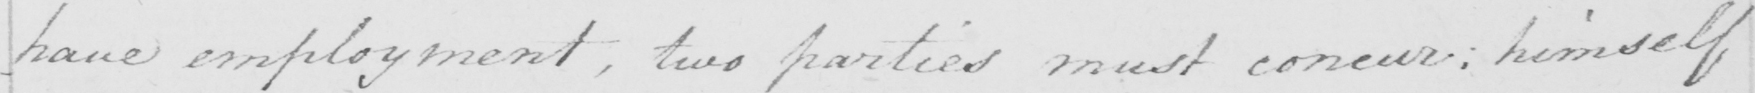Can you read and transcribe this handwriting? have employment , two parties must concur :  himself 